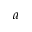<formula> <loc_0><loc_0><loc_500><loc_500>^ { a }</formula> 